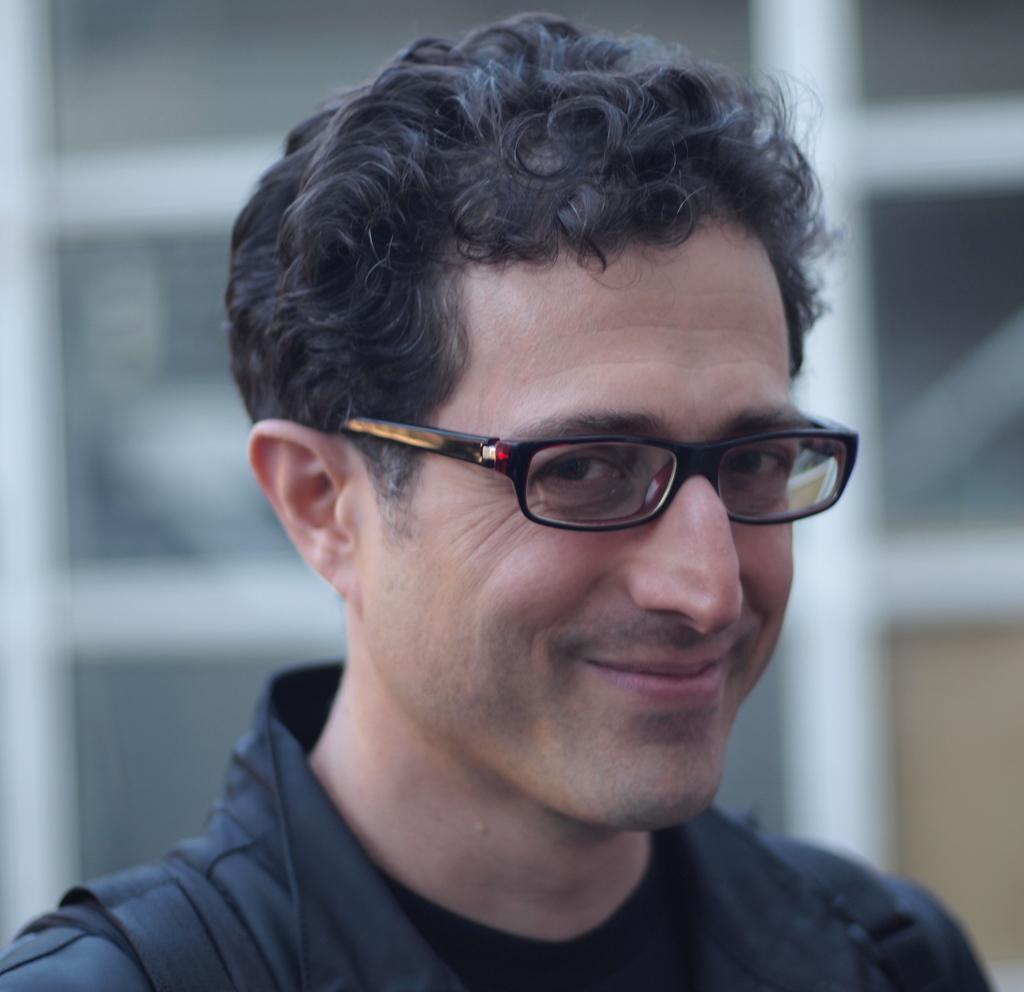Can you describe this image briefly? In this image I can see a person is wearing specs and black color dress. Background is blurred. 